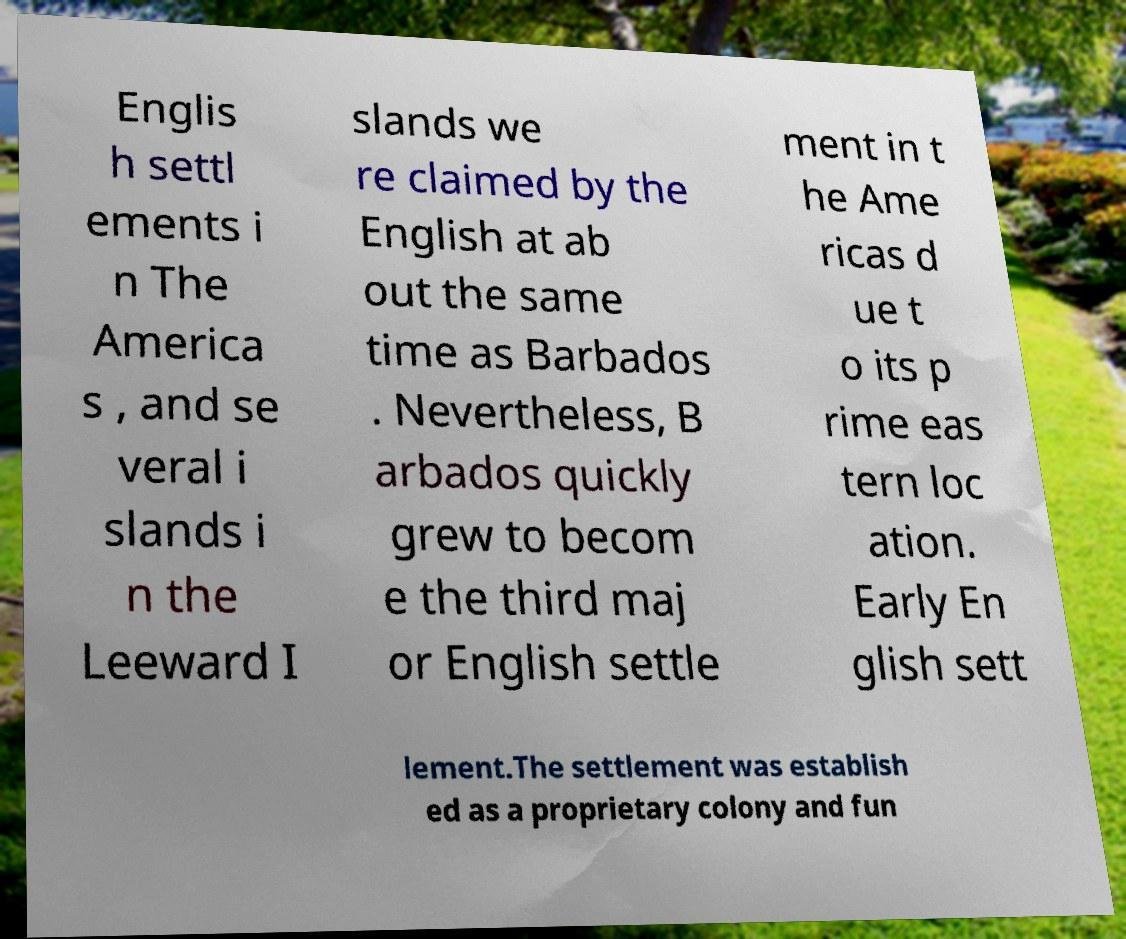What messages or text are displayed in this image? I need them in a readable, typed format. Englis h settl ements i n The America s , and se veral i slands i n the Leeward I slands we re claimed by the English at ab out the same time as Barbados . Nevertheless, B arbados quickly grew to becom e the third maj or English settle ment in t he Ame ricas d ue t o its p rime eas tern loc ation. Early En glish sett lement.The settlement was establish ed as a proprietary colony and fun 